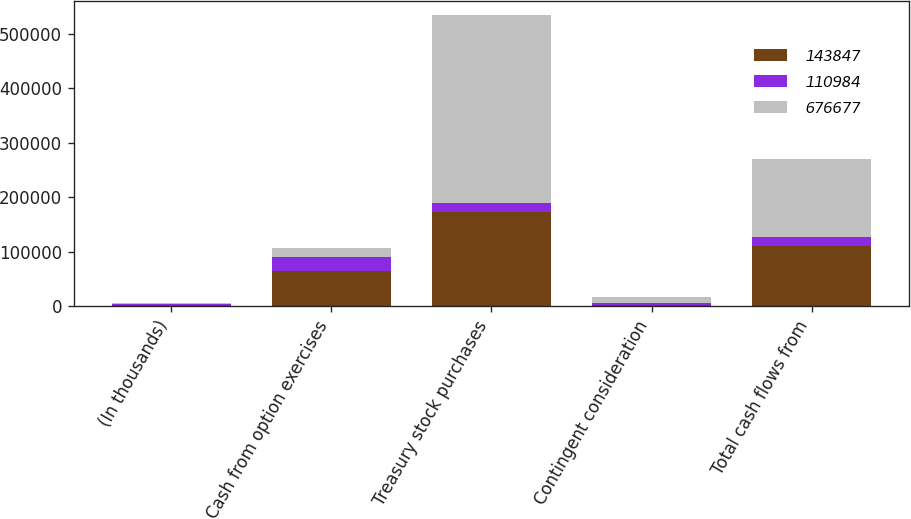Convert chart to OTSL. <chart><loc_0><loc_0><loc_500><loc_500><stacked_bar_chart><ecel><fcel>(In thousands)<fcel>Cash from option exercises<fcel>Treasury stock purchases<fcel>Contingent consideration<fcel>Total cash flows from<nl><fcel>143847<fcel>2017<fcel>65121<fcel>173434<fcel>2671<fcel>110984<nl><fcel>110984<fcel>2016<fcel>25672<fcel>15032<fcel>2074<fcel>15032<nl><fcel>676677<fcel>2015<fcel>15032<fcel>345057<fcel>11012<fcel>143847<nl></chart> 